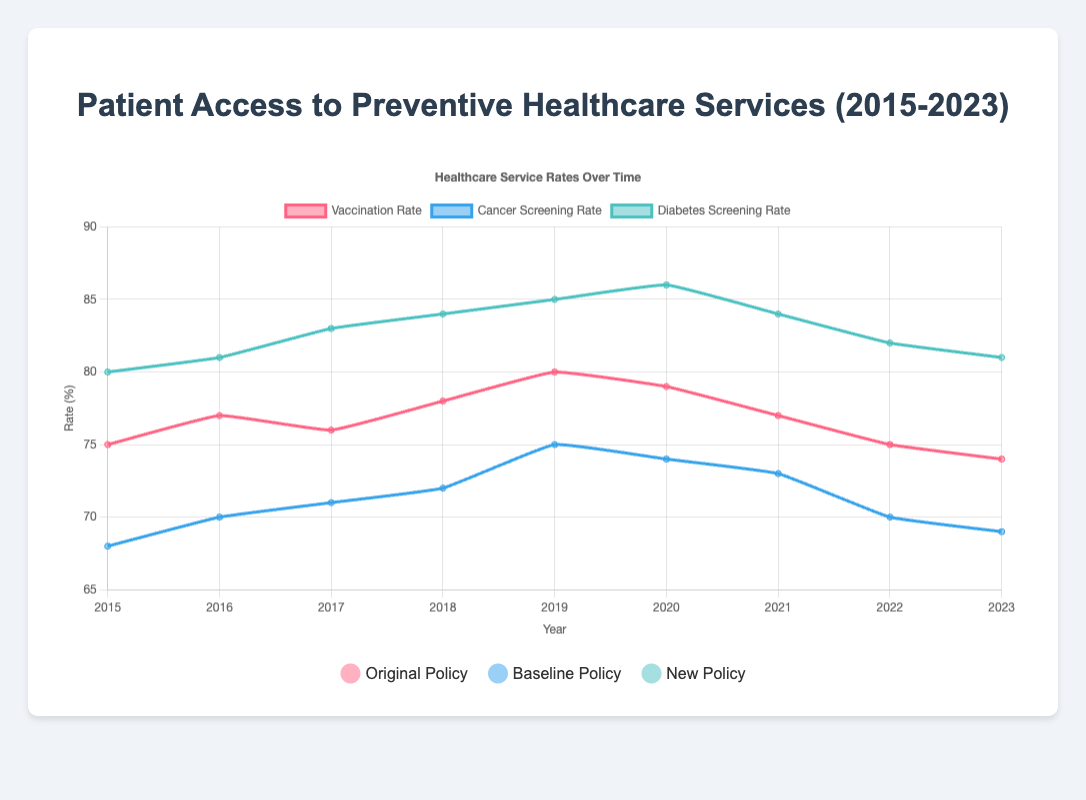What is the overall trend in the vaccination rate from 2015 to 2023? The vaccination rate starts at 75% in 2015, increases to a peak of 80% in 2019, and then decreases to 74% by 2023. The overall trend is an initial increase followed by a decline.
Answer: Initial increase followed by a decline Did the cancer screening rate improve after the implementation of the Baseline Policy in 2018? Before the Baseline Policy in 2018, cancer screening rates were increasing steadily. Post-implementation, the rate peaked in 2019, then slightly declined but remained higher than pre-2018 levels.
Answer: Slight improvement Which year saw the highest diabetes screening rate? To find the highest diabetes screening rate, you look at the values for each year. The highest rate is 86%, which occurred in 2020.
Answer: 2020 How did the New Policy affect the cancer screening rate compared to the Baseline Policy? Under the Baseline Policy, the cancer screening rate reached 75% at its peak. After implementing the New Policy in 2021, it gradually declined from 73% to 69% by 2023. Hence, the New Policy led to a decline.
Answer: Declined Between 2020 and 2021, how did the vaccination rate change? Check the vaccination rates for 2020 and 2021. The rate decreased from 79% in 2020 to 77% in 2021.
Answer: Decreased When comparing the policies, which one had the highest overall increase in diabetes screening rates during its implementation period? For Original Policy (2015-2017), the increase is from 80% to 83%. For Baseline Policy (2018-2020), it increases from 84% to 86%. Under the New Policy (2021-2023), it decreases from 84% to 81%. The Baseline Policy had the highest overall increase.
Answer: Baseline Policy What is the average vaccination rate over the years covered by the New Policy? Data for the New Policy covers 2021 to 2023 with vaccination rates of 77%, 75%, and 74%. The average is (77 + 75 + 74)/3 ≈ 75.33%.
Answer: 75.33% Which policy period had the greatest increase in cancer screening rates? Under the Original Policy, the rate increased from 68% to 71%. Under the Baseline Policy, it increased from 72% to 74%. Under the New Policy, it decreased from 73% to 69%. The greatest increase occurred during the Original Policy period.
Answer: Original Policy What is the visual difference in color for the data points representing the Original and New Policy in the plot? The Original Policy is represented by red-colored data points, whereas the New Policy is represented by blue-colored data points.
Answer: Red and Blue 